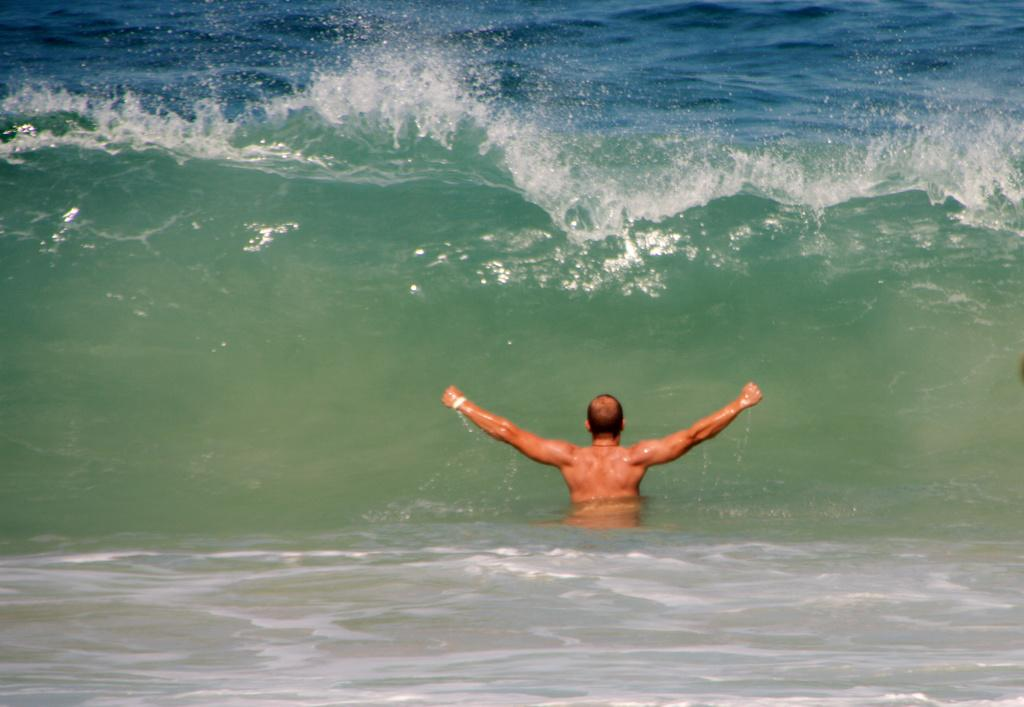Who is the main subject in the image? There is a man in the center of the image. What is the man's location in relation to the water? The man is in the water. Can you describe the environment in the image? There is water visible in the image. What type of copper animal can be seen in the image? There is no copper animal present in the image. 